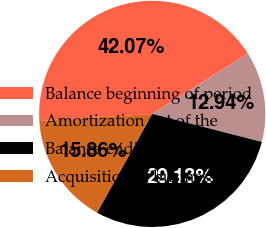Convert chart. <chart><loc_0><loc_0><loc_500><loc_500><pie_chart><fcel>Balance beginning of period<fcel>Amortization net of the<fcel>Balance ending of period<fcel>Acquisition of business<nl><fcel>42.07%<fcel>12.94%<fcel>29.13%<fcel>15.86%<nl></chart> 